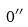<formula> <loc_0><loc_0><loc_500><loc_500>0 ^ { \prime \prime }</formula> 